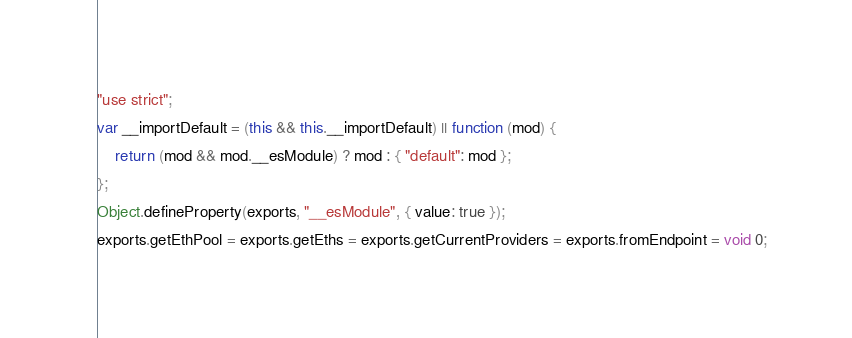<code> <loc_0><loc_0><loc_500><loc_500><_JavaScript_>"use strict";
var __importDefault = (this && this.__importDefault) || function (mod) {
    return (mod && mod.__esModule) ? mod : { "default": mod };
};
Object.defineProperty(exports, "__esModule", { value: true });
exports.getEthPool = exports.getEths = exports.getCurrentProviders = exports.fromEndpoint = void 0;</code> 